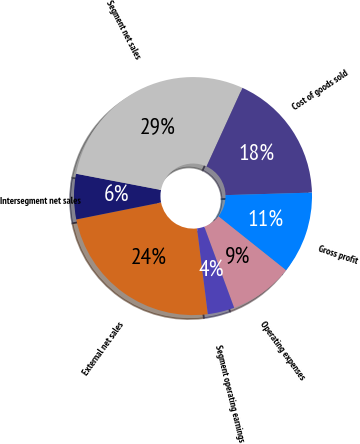Convert chart to OTSL. <chart><loc_0><loc_0><loc_500><loc_500><pie_chart><fcel>External net sales<fcel>Intersegment net sales<fcel>Segment net sales<fcel>Cost of goods sold<fcel>Gross profit<fcel>Operating expenses<fcel>Segment operating earnings<nl><fcel>23.85%<fcel>6.15%<fcel>28.81%<fcel>17.72%<fcel>11.18%<fcel>8.67%<fcel>3.63%<nl></chart> 